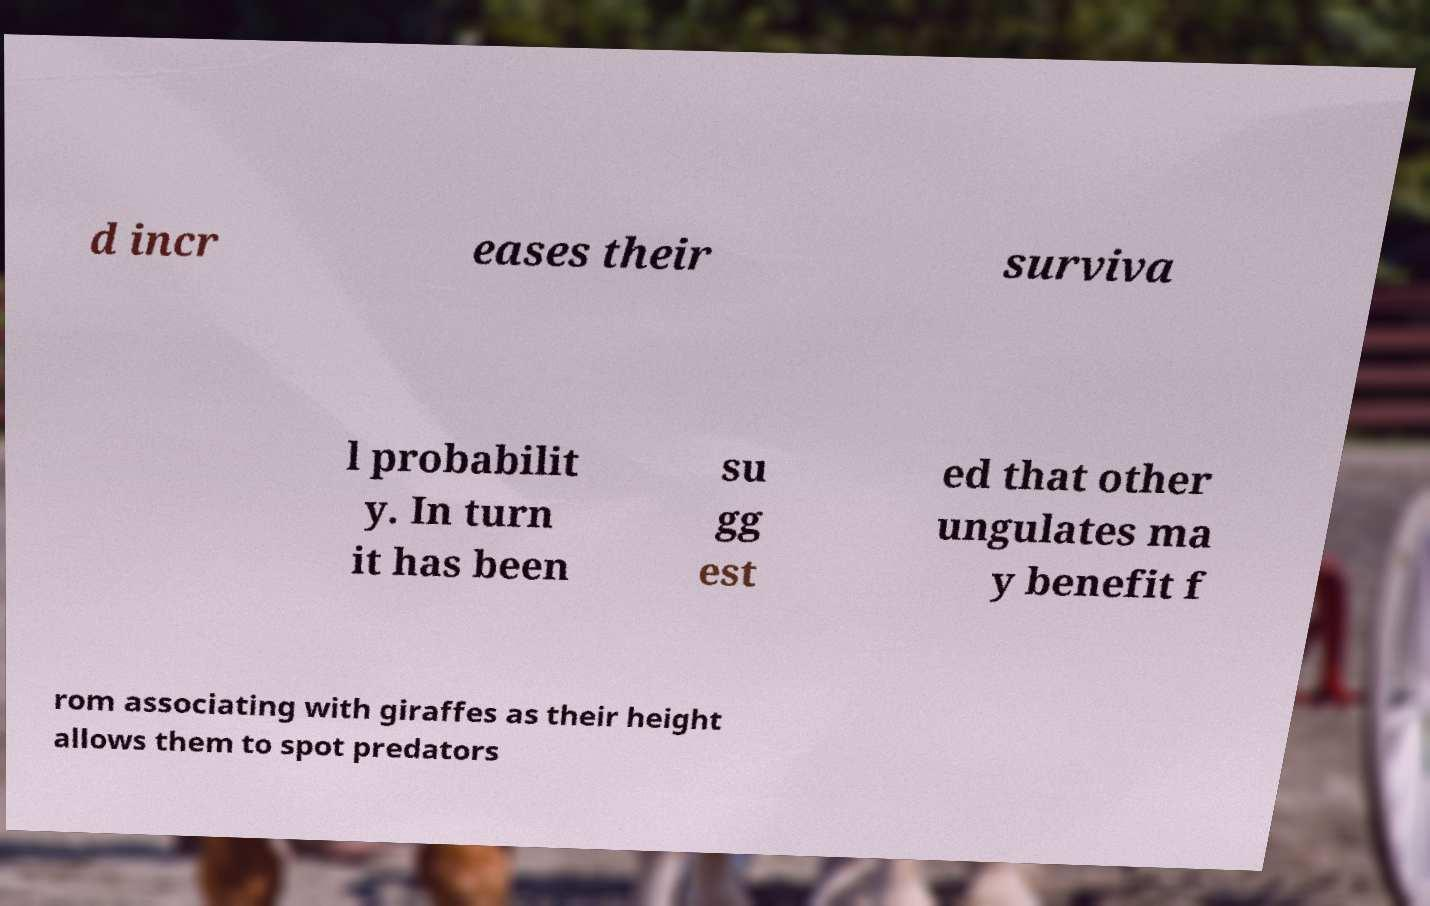Could you extract and type out the text from this image? d incr eases their surviva l probabilit y. In turn it has been su gg est ed that other ungulates ma y benefit f rom associating with giraffes as their height allows them to spot predators 